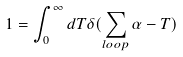<formula> <loc_0><loc_0><loc_500><loc_500>1 = \int _ { 0 } ^ { \infty } d T \delta ( \sum _ { l o o p } \alpha - T )</formula> 